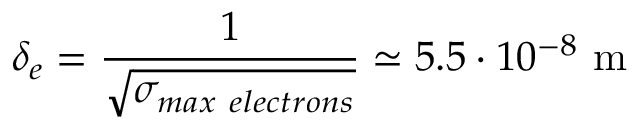Convert formula to latex. <formula><loc_0><loc_0><loc_500><loc_500>\delta _ { e } = \frac { 1 } { \sqrt { \sigma _ { \max e l e c t r o n s } } } \simeq 5 . 5 \cdot 1 0 ^ { - 8 } m</formula> 